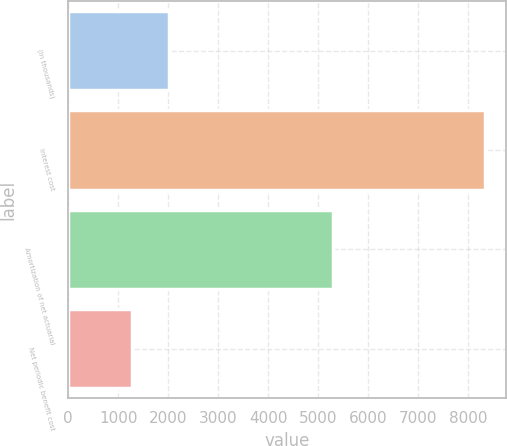Convert chart to OTSL. <chart><loc_0><loc_0><loc_500><loc_500><bar_chart><fcel>(In thousands)<fcel>Interest cost<fcel>Amortization of net actuarial<fcel>Net periodic benefit cost<nl><fcel>2011<fcel>8336<fcel>5290<fcel>1283<nl></chart> 